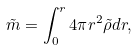<formula> <loc_0><loc_0><loc_500><loc_500>\tilde { m } = \int _ { 0 } ^ { r } 4 \pi r ^ { 2 } \tilde { \rho } d r ,</formula> 